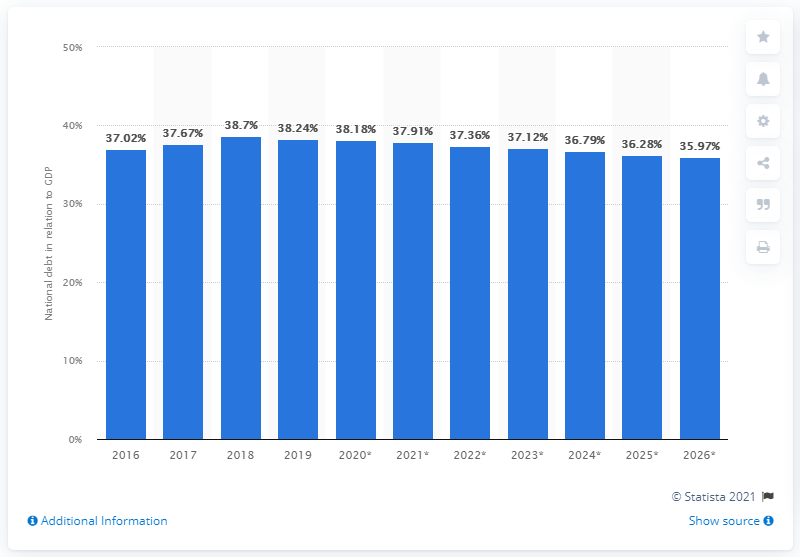Highlight a few significant elements in this photo. In 2019, the national debt of Tanzania accounted for 37.91% of the country's Gross Domestic Product (GDP). 